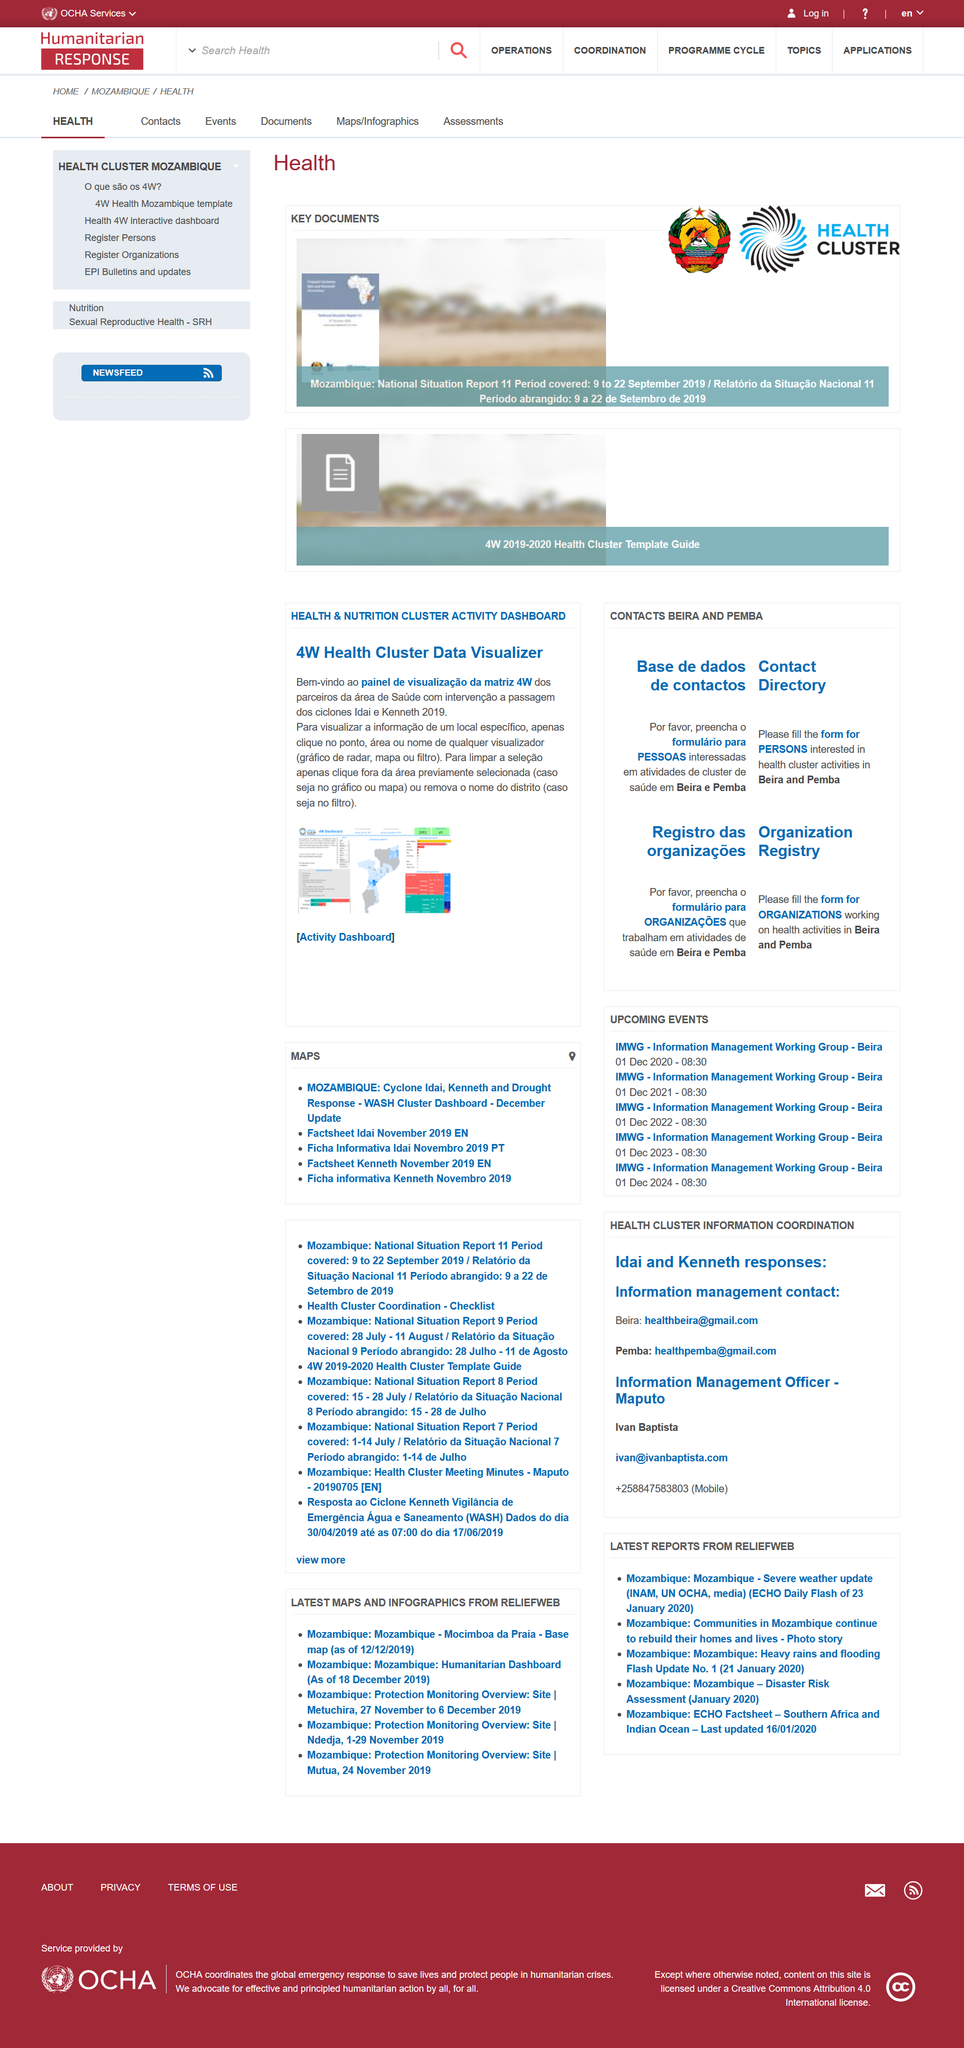Give some essential details in this illustration. The value is not available as it is not applicable The value is not available or applicable. The value is not available or has not been provided. 